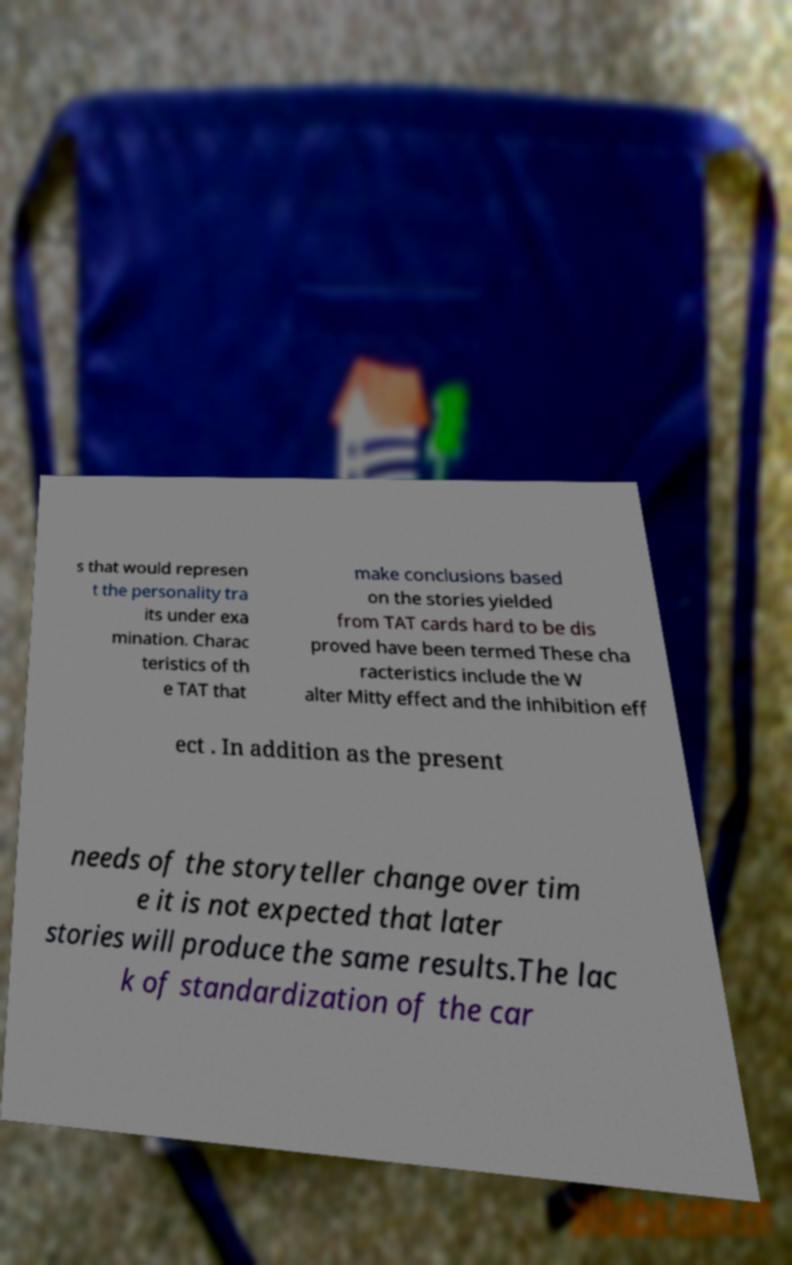Could you extract and type out the text from this image? s that would represen t the personality tra its under exa mination. Charac teristics of th e TAT that make conclusions based on the stories yielded from TAT cards hard to be dis proved have been termed These cha racteristics include the W alter Mitty effect and the inhibition eff ect . In addition as the present needs of the storyteller change over tim e it is not expected that later stories will produce the same results.The lac k of standardization of the car 